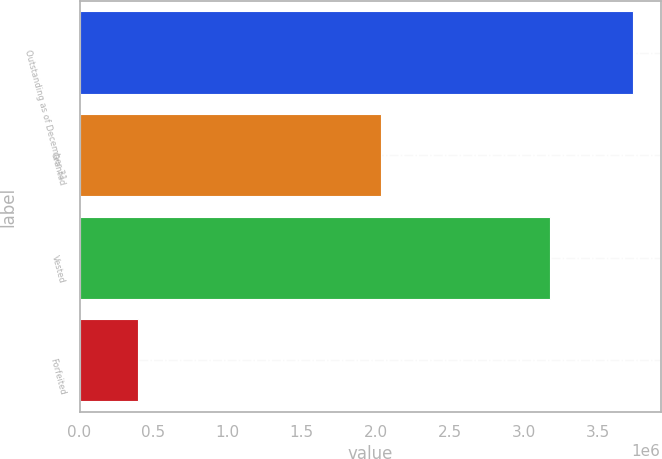<chart> <loc_0><loc_0><loc_500><loc_500><bar_chart><fcel>Outstanding as of December 31<fcel>Granted<fcel>Vested<fcel>Forfeited<nl><fcel>3.73825e+06<fcel>2.03864e+06<fcel>3.18016e+06<fcel>397140<nl></chart> 